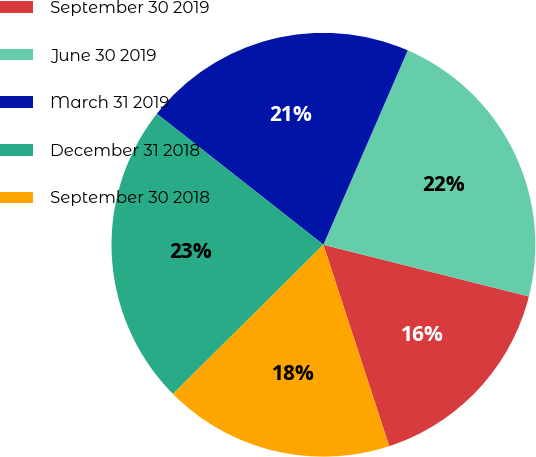Convert chart to OTSL. <chart><loc_0><loc_0><loc_500><loc_500><pie_chart><fcel>September 30 2019<fcel>June 30 2019<fcel>March 31 2019<fcel>December 31 2018<fcel>September 30 2018<nl><fcel>16.05%<fcel>22.41%<fcel>20.91%<fcel>23.04%<fcel>17.59%<nl></chart> 